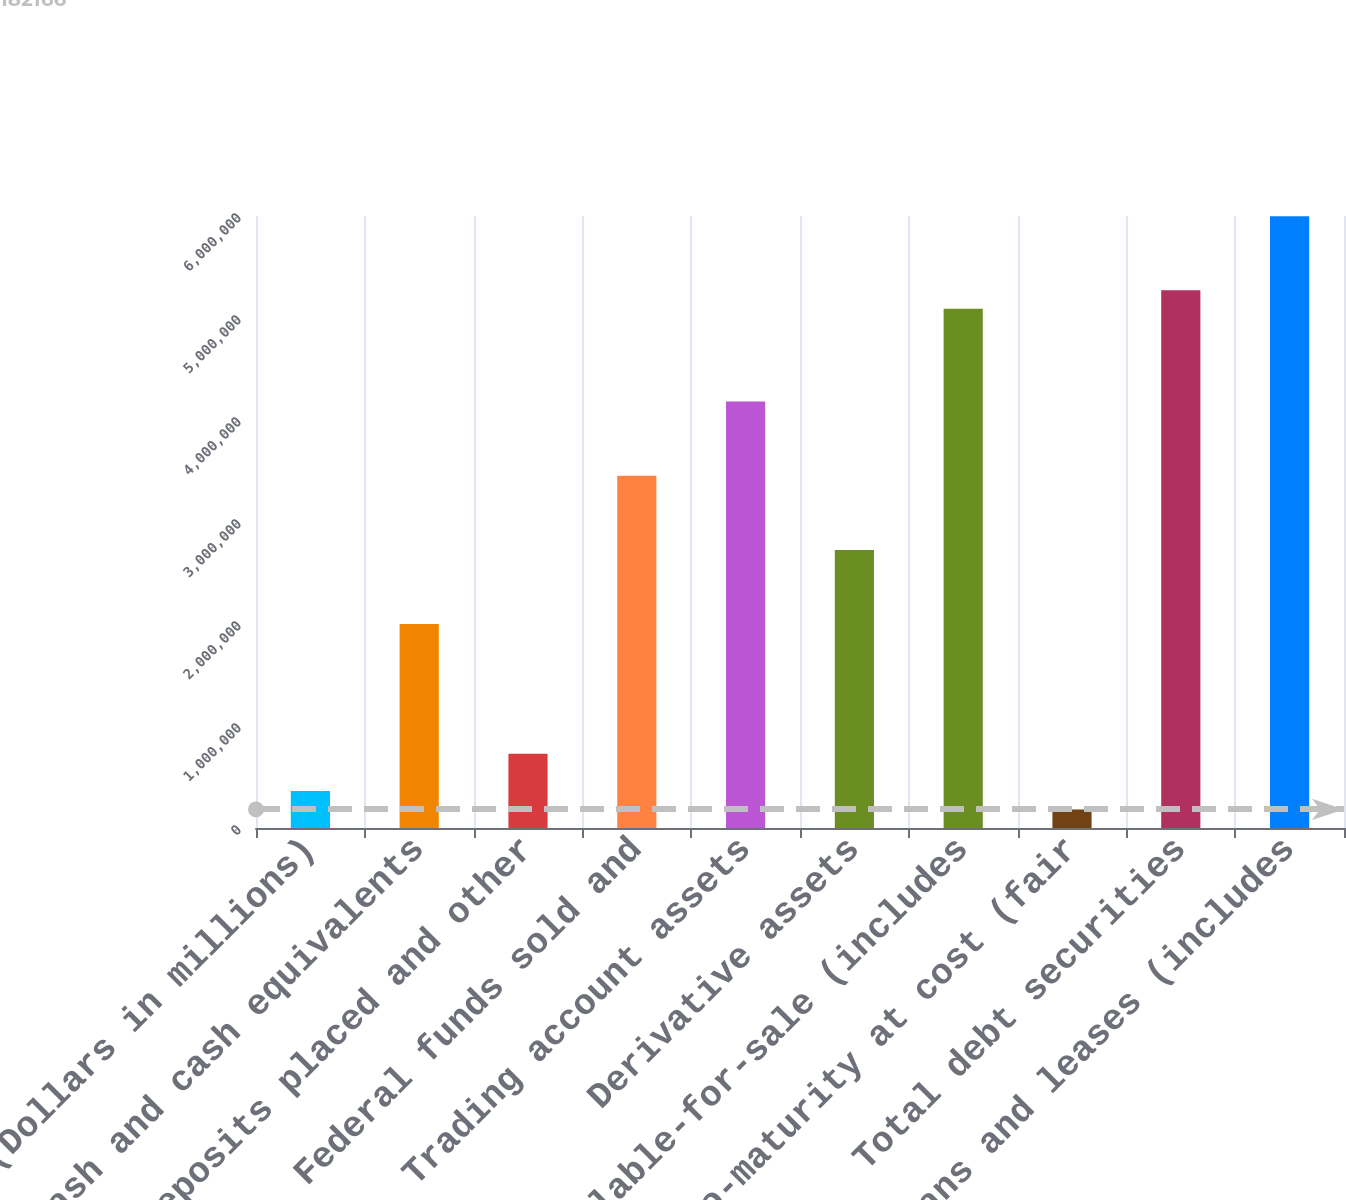<chart> <loc_0><loc_0><loc_500><loc_500><bar_chart><fcel>(Dollars in millions)<fcel>Cash and cash equivalents<fcel>Time deposits placed and other<fcel>Federal funds sold and<fcel>Trading account assets<fcel>Derivative assets<fcel>Available-for-sale (includes<fcel>Held-to-maturity at cost (fair<fcel>Total debt securities<fcel>Loans and leases (includes<nl><fcel>363919<fcel>1.9997e+06<fcel>727425<fcel>3.45372e+06<fcel>4.18073e+06<fcel>2.72671e+06<fcel>5.0895e+06<fcel>182166<fcel>5.27125e+06<fcel>5.99826e+06<nl></chart> 